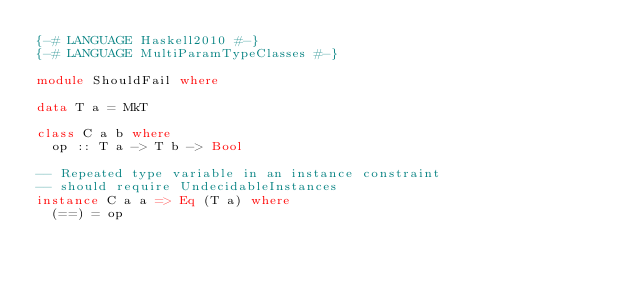<code> <loc_0><loc_0><loc_500><loc_500><_Haskell_>{-# LANGUAGE Haskell2010 #-}
{-# LANGUAGE MultiParamTypeClasses #-}

module ShouldFail where

data T a = MkT

class C a b where
  op :: T a -> T b -> Bool

-- Repeated type variable in an instance constraint
-- should require UndecidableInstances
instance C a a => Eq (T a) where
  (==) = op
</code> 